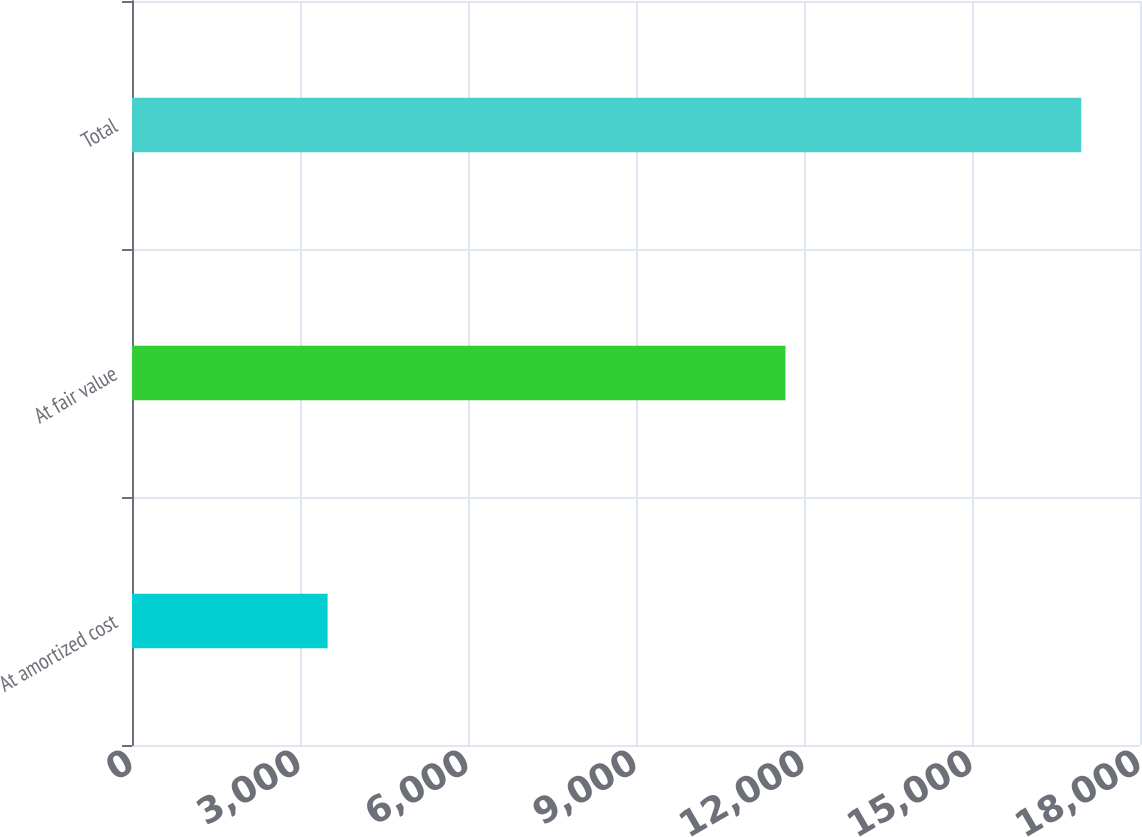Convert chart. <chart><loc_0><loc_0><loc_500><loc_500><bar_chart><fcel>At amortized cost<fcel>At fair value<fcel>Total<nl><fcel>3493<fcel>11669<fcel>16951<nl></chart> 